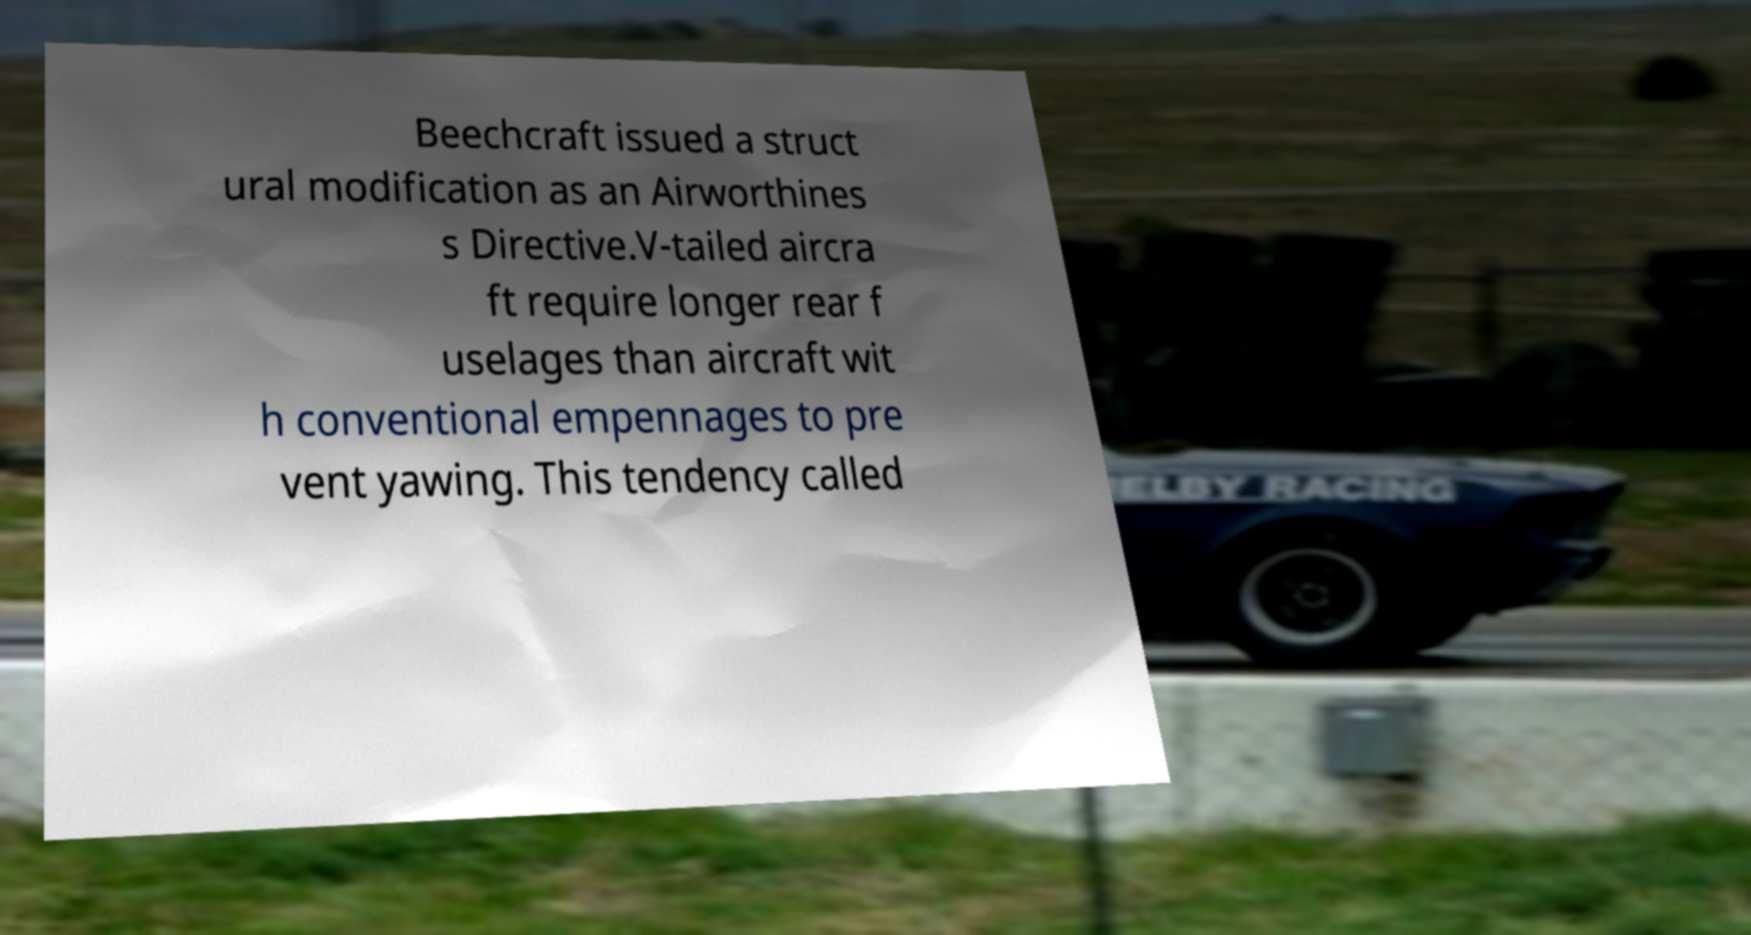Could you extract and type out the text from this image? Beechcraft issued a struct ural modification as an Airworthines s Directive.V-tailed aircra ft require longer rear f uselages than aircraft wit h conventional empennages to pre vent yawing. This tendency called 